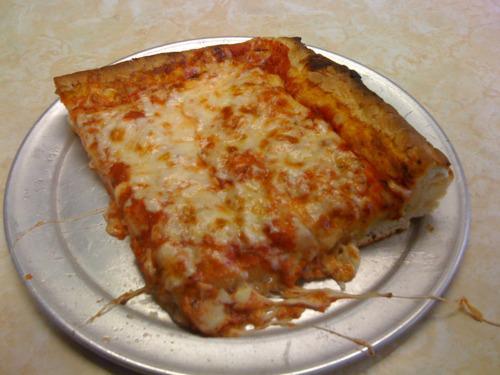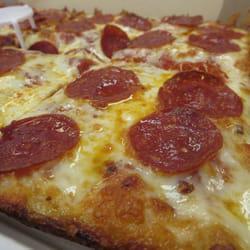The first image is the image on the left, the second image is the image on the right. Considering the images on both sides, is "The pizzas in both images are not circles, but are shaped like rectangles instead." valid? Answer yes or no. Yes. The first image is the image on the left, the second image is the image on the right. Evaluate the accuracy of this statement regarding the images: "No image shows a round pizza or triangular slice, and one image shows less than a complete rectangular pizza.". Is it true? Answer yes or no. Yes. 